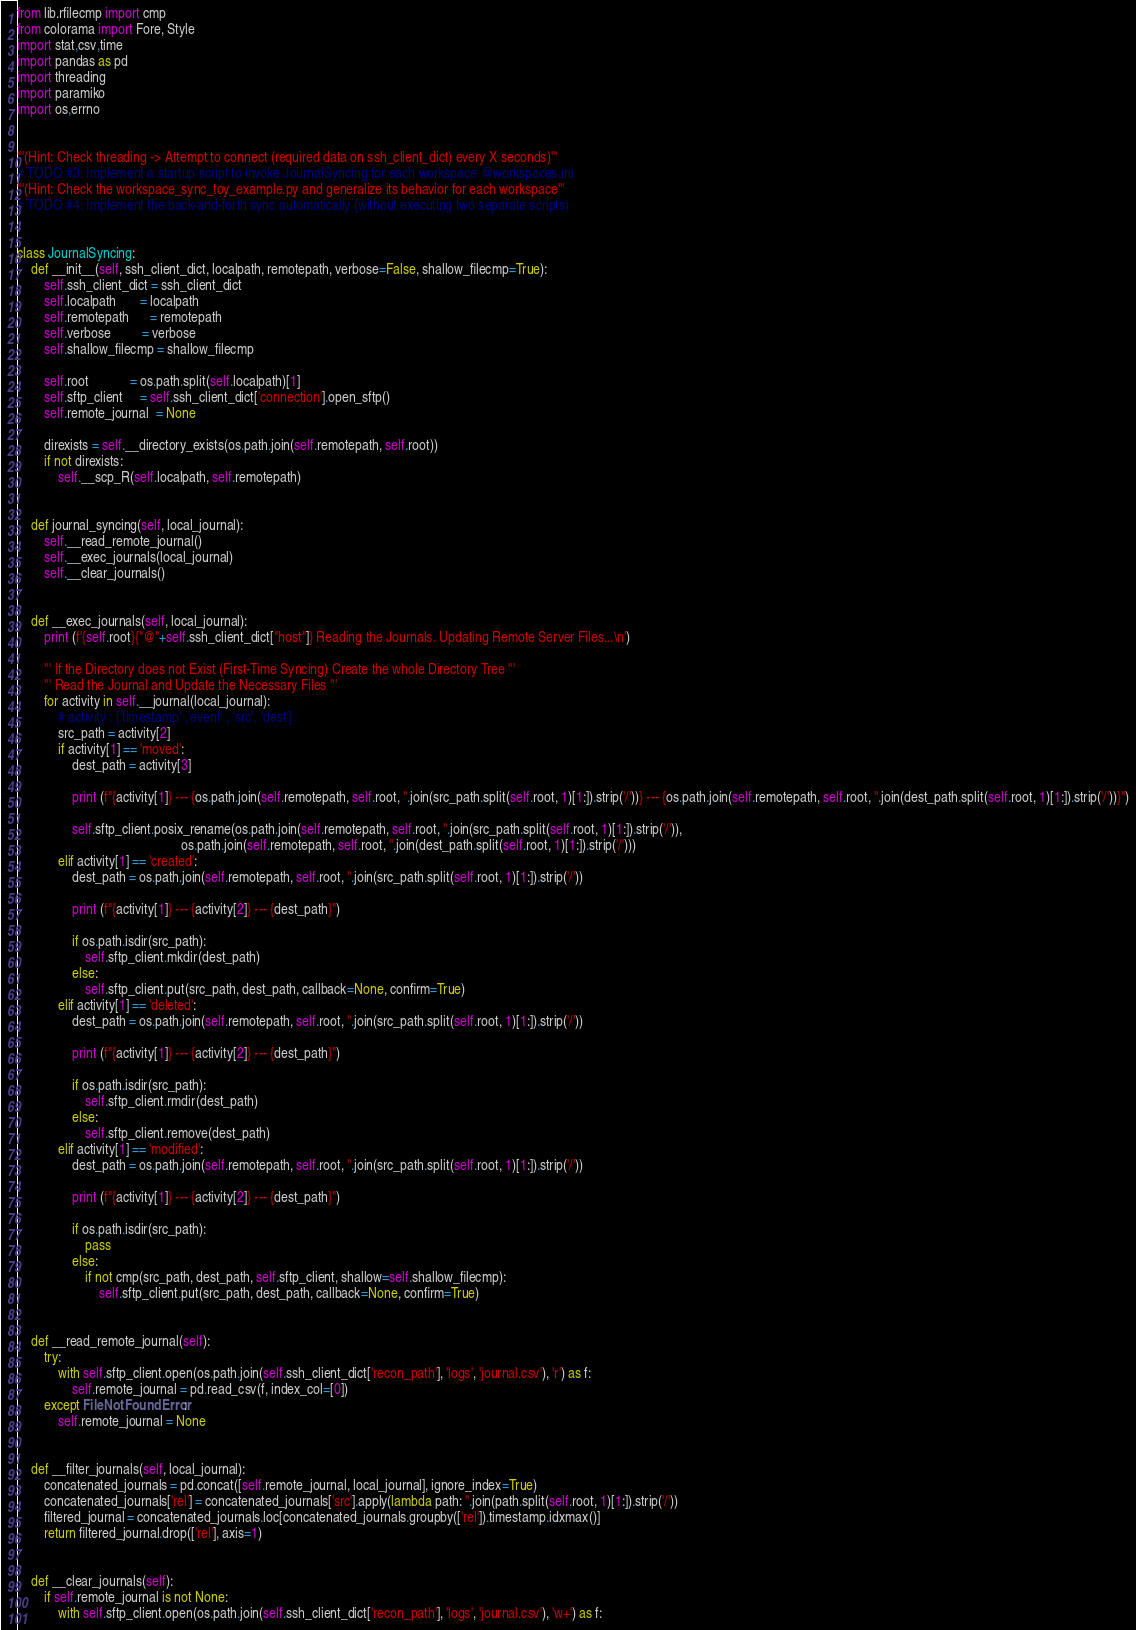<code> <loc_0><loc_0><loc_500><loc_500><_Python_>from lib.rfilecmp import cmp
from colorama import Fore, Style
import stat,csv,time
import pandas as pd
import threading
import paramiko
import os,errno


'''(Hint: Check threading -> Attempt to connect (required data on ssh_client_dict) every X seconds)'''
# TODO #3: Implement a startup script to invoke JournalSyncing for each workspace @workspaces.ini
'''(Hint: Check the workspace_sync_toy_example.py and generalize its behavior for each workspace'''
# TODO #4: Implement the back-and-forth sync automatically (without executing two separate scripts)


class JournalSyncing:
    def __init__(self, ssh_client_dict, localpath, remotepath, verbose=False, shallow_filecmp=True):   
        self.ssh_client_dict = ssh_client_dict
        self.localpath       = localpath
        self.remotepath      = remotepath
        self.verbose         = verbose
        self.shallow_filecmp = shallow_filecmp

        self.root            = os.path.split(self.localpath)[1]
        self.sftp_client     = self.ssh_client_dict['connection'].open_sftp()
        self.remote_journal  = None

        direxists = self.__directory_exists(os.path.join(self.remotepath, self.root))
        if not direxists:
            self.__scp_R(self.localpath, self.remotepath)        


    def journal_syncing(self, local_journal):
        self.__read_remote_journal()
        self.__exec_journals(local_journal)
        self.__clear_journals()
        

    def __exec_journals(self, local_journal):
        print (f'{self.root}{"@"+self.ssh_client_dict["host"]} Reading the Journals. Updating Remote Server Files...\n')
        
        ''' If the Directory does not Exist (First-Time Syncing) Create the whole Directory Tree '''
        ''' Read the Journal and Update the Necessary Files '''
        for activity in self.__journal(local_journal):
            # activity : ['timestamp' ,'event' , 'src', 'dest']
            src_path = activity[2]
            if activity[1] == 'moved':
                dest_path = activity[3]
                
                print (f"{activity[1]} --- {os.path.join(self.remotepath, self.root, ''.join(src_path.split(self.root, 1)[1:]).strip('/'))} --- {os.path.join(self.remotepath, self.root, ''.join(dest_path.split(self.root, 1)[1:]).strip('/'))}")
                
                self.sftp_client.posix_rename(os.path.join(self.remotepath, self.root, ''.join(src_path.split(self.root, 1)[1:]).strip('/')), 
                                                os.path.join(self.remotepath, self.root, ''.join(dest_path.split(self.root, 1)[1:]).strip('/')))
            elif activity[1] == 'created':
                dest_path = os.path.join(self.remotepath, self.root, ''.join(src_path.split(self.root, 1)[1:]).strip('/'))
                
                print (f"{activity[1]} --- {activity[2]} --- {dest_path}")
                
                if os.path.isdir(src_path):
                    self.sftp_client.mkdir(dest_path)
                else:
                    self.sftp_client.put(src_path, dest_path, callback=None, confirm=True)
            elif activity[1] == 'deleted':
                dest_path = os.path.join(self.remotepath, self.root, ''.join(src_path.split(self.root, 1)[1:]).strip('/'))
                
                print (f"{activity[1]} --- {activity[2]} --- {dest_path}")
                
                if os.path.isdir(src_path):
                    self.sftp_client.rmdir(dest_path)  
                else:
                    self.sftp_client.remove(dest_path)  
            elif activity[1] == 'modified':
                dest_path = os.path.join(self.remotepath, self.root, ''.join(src_path.split(self.root, 1)[1:]).strip('/'))
                
                print (f"{activity[1]} --- {activity[2]} --- {dest_path}")
                
                if os.path.isdir(src_path):
                    pass
                else:
                    if not cmp(src_path, dest_path, self.sftp_client, shallow=self.shallow_filecmp):
                        self.sftp_client.put(src_path, dest_path, callback=None, confirm=True)            


    def __read_remote_journal(self):     
        try:
            with self.sftp_client.open(os.path.join(self.ssh_client_dict['recon_path'], 'logs', 'journal.csv'), 'r') as f:
                self.remote_journal = pd.read_csv(f, index_col=[0])
        except FileNotFoundError:
            self.remote_journal = None


    def __filter_journals(self, local_journal):
        concatenated_journals = pd.concat([self.remote_journal, local_journal], ignore_index=True)
        concatenated_journals['rel'] = concatenated_journals['src'].apply(lambda path: ''.join(path.split(self.root, 1)[1:]).strip('/'))
        filtered_journal = concatenated_journals.loc[concatenated_journals.groupby(['rel']).timestamp.idxmax()]
        return filtered_journal.drop(['rel'], axis=1)


    def __clear_journals(self):
        if self.remote_journal is not None:
            with self.sftp_client.open(os.path.join(self.ssh_client_dict['recon_path'], 'logs', 'journal.csv'), 'w+') as f:</code> 